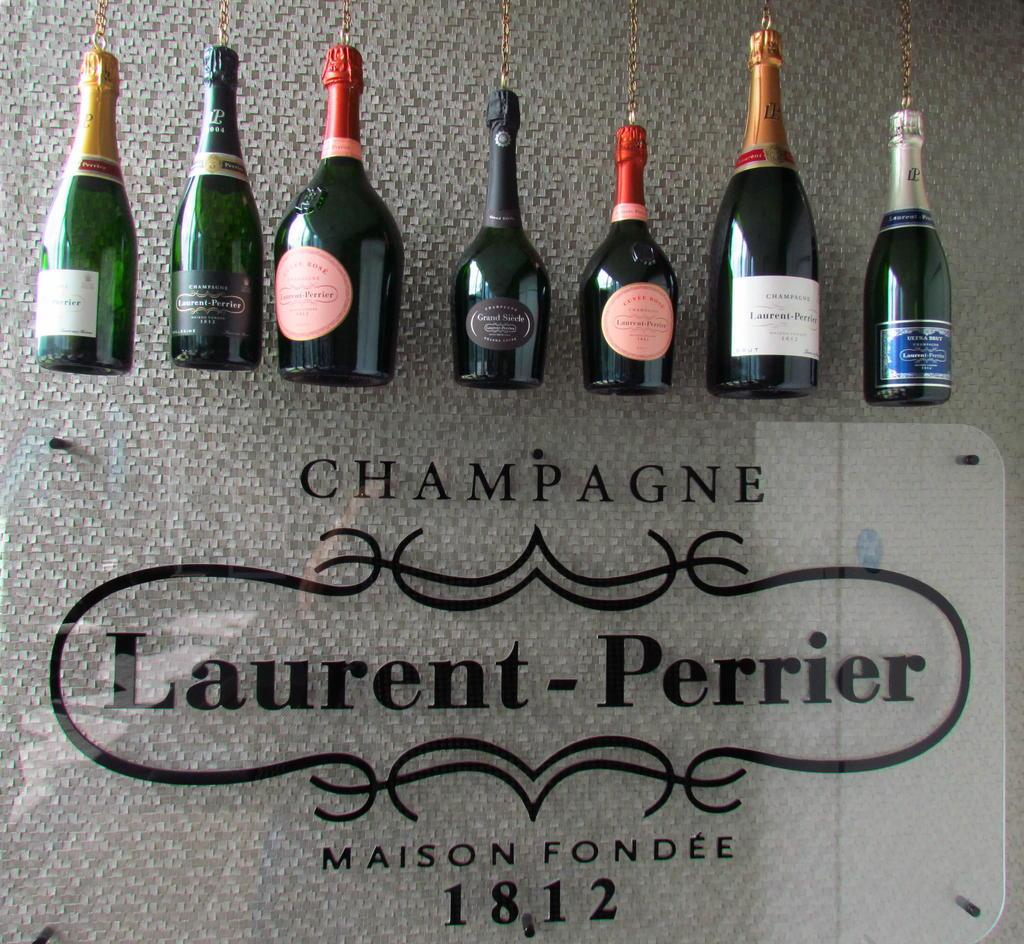<image>
Offer a succinct explanation of the picture presented. Bottles of champange on the wall and the year 1812 on the bottom. 